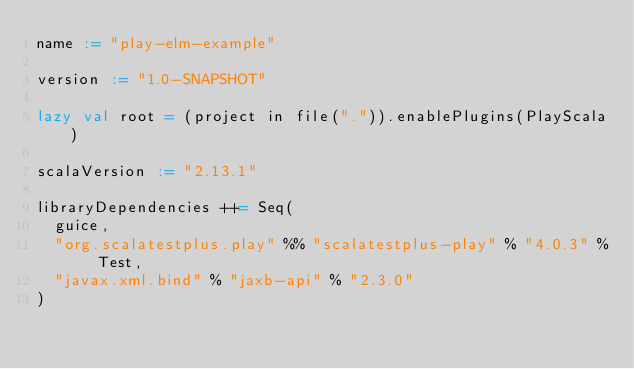<code> <loc_0><loc_0><loc_500><loc_500><_Scala_>name := "play-elm-example"

version := "1.0-SNAPSHOT"

lazy val root = (project in file(".")).enablePlugins(PlayScala)

scalaVersion := "2.13.1"

libraryDependencies ++= Seq(
  guice,
  "org.scalatestplus.play" %% "scalatestplus-play" % "4.0.3" % Test,
  "javax.xml.bind" % "jaxb-api" % "2.3.0"
)
</code> 